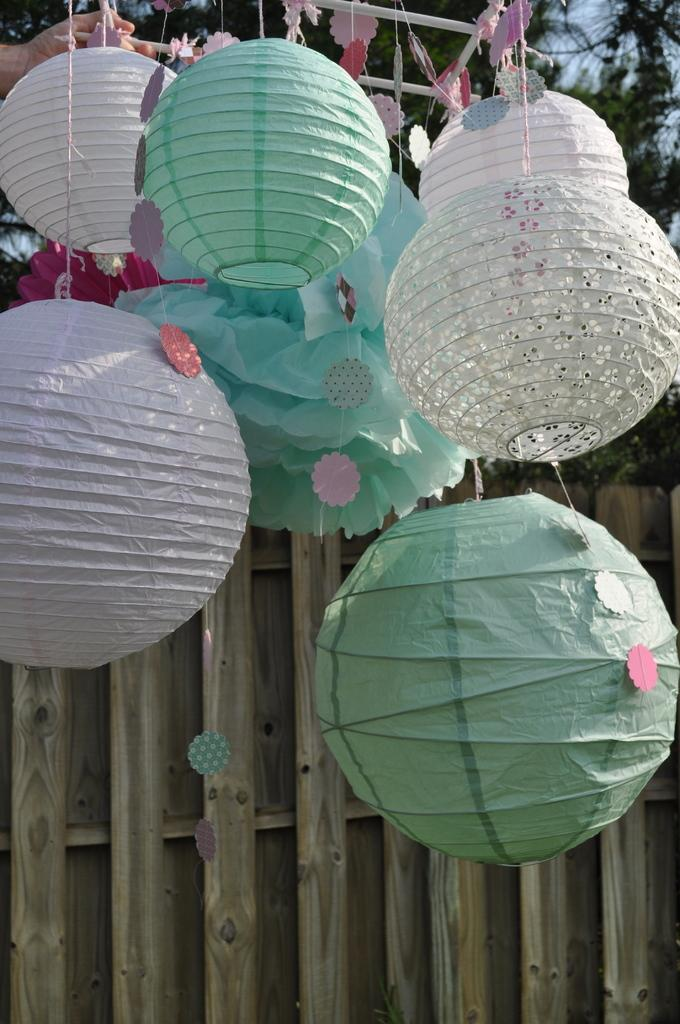What type of decorations can be seen hanging in the image? There are paper lanterns hanging in the image. How are the paper lanterns suspended? The paper lanterns are hanging from a rod. What type of material is the wall at the bottom of the image made of? The wall at the bottom of the image is made of wood. What natural elements can be seen at the top of the image? Trees and the sky are visible at the top of the image. Can you see a lake in the image? No, there is no lake present in the image. What type of screw is used to attach the paper lanterns to the rod? There is no mention of screws in the image, as the paper lanterns are simply hanging from the rod. 